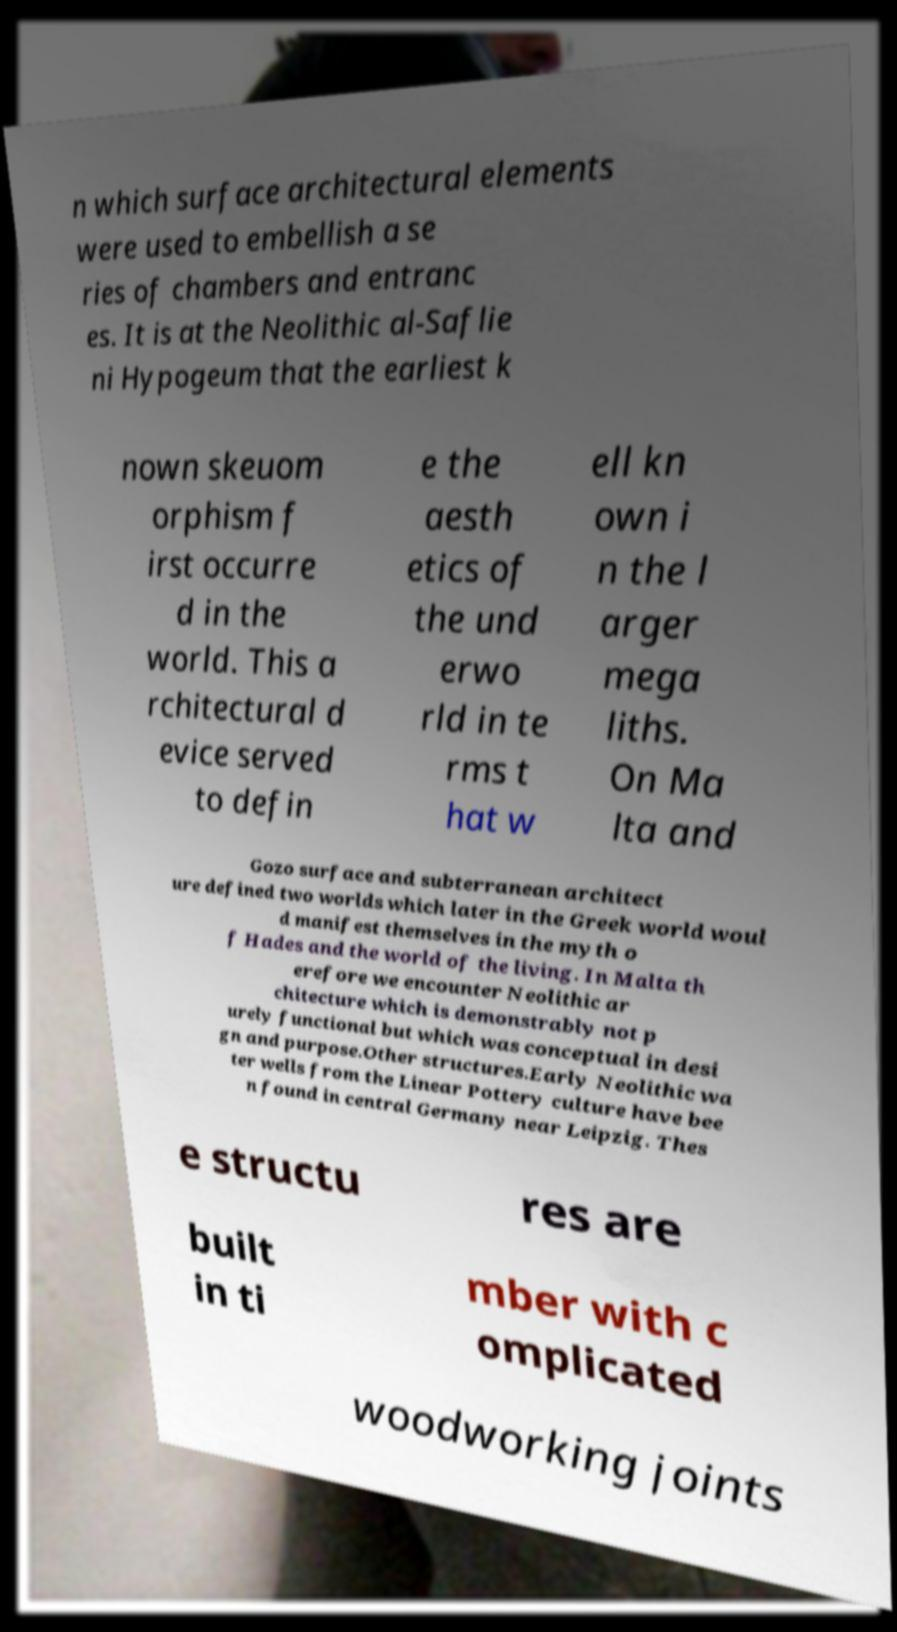There's text embedded in this image that I need extracted. Can you transcribe it verbatim? n which surface architectural elements were used to embellish a se ries of chambers and entranc es. It is at the Neolithic al-Saflie ni Hypogeum that the earliest k nown skeuom orphism f irst occurre d in the world. This a rchitectural d evice served to defin e the aesth etics of the und erwo rld in te rms t hat w ell kn own i n the l arger mega liths. On Ma lta and Gozo surface and subterranean architect ure defined two worlds which later in the Greek world woul d manifest themselves in the myth o f Hades and the world of the living. In Malta th erefore we encounter Neolithic ar chitecture which is demonstrably not p urely functional but which was conceptual in desi gn and purpose.Other structures.Early Neolithic wa ter wells from the Linear Pottery culture have bee n found in central Germany near Leipzig. Thes e structu res are built in ti mber with c omplicated woodworking joints 